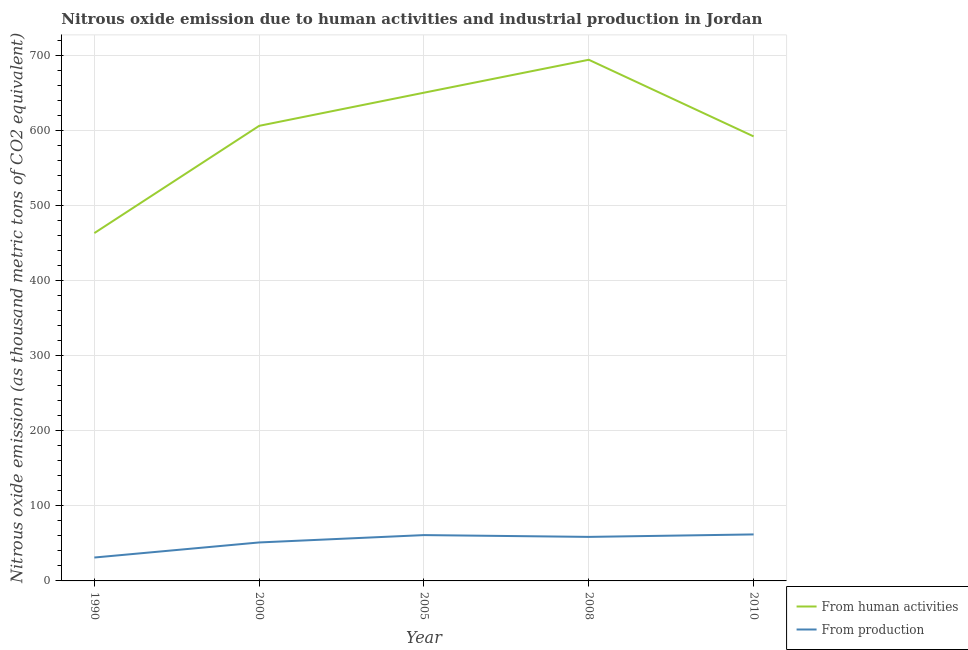Does the line corresponding to amount of emissions from human activities intersect with the line corresponding to amount of emissions generated from industries?
Your response must be concise. No. Is the number of lines equal to the number of legend labels?
Provide a succinct answer. Yes. What is the amount of emissions from human activities in 1990?
Give a very brief answer. 463.8. Across all years, what is the maximum amount of emissions from human activities?
Provide a succinct answer. 694.9. Across all years, what is the minimum amount of emissions from human activities?
Keep it short and to the point. 463.8. What is the total amount of emissions generated from industries in the graph?
Your answer should be very brief. 264.3. What is the difference between the amount of emissions from human activities in 1990 and that in 2000?
Offer a very short reply. -143. What is the difference between the amount of emissions from human activities in 2010 and the amount of emissions generated from industries in 1990?
Make the answer very short. 561.5. What is the average amount of emissions generated from industries per year?
Ensure brevity in your answer.  52.86. In the year 2008, what is the difference between the amount of emissions from human activities and amount of emissions generated from industries?
Provide a short and direct response. 636.2. What is the ratio of the amount of emissions from human activities in 2000 to that in 2005?
Keep it short and to the point. 0.93. Is the difference between the amount of emissions generated from industries in 2000 and 2010 greater than the difference between the amount of emissions from human activities in 2000 and 2010?
Offer a very short reply. No. What is the difference between the highest and the second highest amount of emissions generated from industries?
Offer a very short reply. 0.9. What is the difference between the highest and the lowest amount of emissions generated from industries?
Offer a terse response. 30.8. Does the amount of emissions from human activities monotonically increase over the years?
Your answer should be compact. No. How many lines are there?
Offer a very short reply. 2. Does the graph contain any zero values?
Offer a very short reply. No. Does the graph contain grids?
Ensure brevity in your answer.  Yes. Where does the legend appear in the graph?
Keep it short and to the point. Bottom right. What is the title of the graph?
Provide a short and direct response. Nitrous oxide emission due to human activities and industrial production in Jordan. What is the label or title of the Y-axis?
Offer a very short reply. Nitrous oxide emission (as thousand metric tons of CO2 equivalent). What is the Nitrous oxide emission (as thousand metric tons of CO2 equivalent) of From human activities in 1990?
Your answer should be compact. 463.8. What is the Nitrous oxide emission (as thousand metric tons of CO2 equivalent) in From production in 1990?
Give a very brief answer. 31.2. What is the Nitrous oxide emission (as thousand metric tons of CO2 equivalent) of From human activities in 2000?
Your answer should be compact. 606.8. What is the Nitrous oxide emission (as thousand metric tons of CO2 equivalent) of From production in 2000?
Keep it short and to the point. 51.3. What is the Nitrous oxide emission (as thousand metric tons of CO2 equivalent) in From human activities in 2005?
Make the answer very short. 651. What is the Nitrous oxide emission (as thousand metric tons of CO2 equivalent) of From production in 2005?
Offer a very short reply. 61.1. What is the Nitrous oxide emission (as thousand metric tons of CO2 equivalent) of From human activities in 2008?
Ensure brevity in your answer.  694.9. What is the Nitrous oxide emission (as thousand metric tons of CO2 equivalent) of From production in 2008?
Offer a terse response. 58.7. What is the Nitrous oxide emission (as thousand metric tons of CO2 equivalent) of From human activities in 2010?
Your answer should be compact. 592.7. Across all years, what is the maximum Nitrous oxide emission (as thousand metric tons of CO2 equivalent) of From human activities?
Keep it short and to the point. 694.9. Across all years, what is the minimum Nitrous oxide emission (as thousand metric tons of CO2 equivalent) in From human activities?
Offer a terse response. 463.8. Across all years, what is the minimum Nitrous oxide emission (as thousand metric tons of CO2 equivalent) in From production?
Ensure brevity in your answer.  31.2. What is the total Nitrous oxide emission (as thousand metric tons of CO2 equivalent) of From human activities in the graph?
Offer a very short reply. 3009.2. What is the total Nitrous oxide emission (as thousand metric tons of CO2 equivalent) in From production in the graph?
Keep it short and to the point. 264.3. What is the difference between the Nitrous oxide emission (as thousand metric tons of CO2 equivalent) of From human activities in 1990 and that in 2000?
Make the answer very short. -143. What is the difference between the Nitrous oxide emission (as thousand metric tons of CO2 equivalent) of From production in 1990 and that in 2000?
Your answer should be very brief. -20.1. What is the difference between the Nitrous oxide emission (as thousand metric tons of CO2 equivalent) in From human activities in 1990 and that in 2005?
Provide a succinct answer. -187.2. What is the difference between the Nitrous oxide emission (as thousand metric tons of CO2 equivalent) in From production in 1990 and that in 2005?
Your answer should be very brief. -29.9. What is the difference between the Nitrous oxide emission (as thousand metric tons of CO2 equivalent) in From human activities in 1990 and that in 2008?
Your response must be concise. -231.1. What is the difference between the Nitrous oxide emission (as thousand metric tons of CO2 equivalent) of From production in 1990 and that in 2008?
Your answer should be compact. -27.5. What is the difference between the Nitrous oxide emission (as thousand metric tons of CO2 equivalent) in From human activities in 1990 and that in 2010?
Ensure brevity in your answer.  -128.9. What is the difference between the Nitrous oxide emission (as thousand metric tons of CO2 equivalent) in From production in 1990 and that in 2010?
Your answer should be compact. -30.8. What is the difference between the Nitrous oxide emission (as thousand metric tons of CO2 equivalent) of From human activities in 2000 and that in 2005?
Your answer should be compact. -44.2. What is the difference between the Nitrous oxide emission (as thousand metric tons of CO2 equivalent) in From human activities in 2000 and that in 2008?
Provide a short and direct response. -88.1. What is the difference between the Nitrous oxide emission (as thousand metric tons of CO2 equivalent) of From human activities in 2000 and that in 2010?
Your answer should be compact. 14.1. What is the difference between the Nitrous oxide emission (as thousand metric tons of CO2 equivalent) in From human activities in 2005 and that in 2008?
Your response must be concise. -43.9. What is the difference between the Nitrous oxide emission (as thousand metric tons of CO2 equivalent) of From human activities in 2005 and that in 2010?
Ensure brevity in your answer.  58.3. What is the difference between the Nitrous oxide emission (as thousand metric tons of CO2 equivalent) in From human activities in 2008 and that in 2010?
Provide a succinct answer. 102.2. What is the difference between the Nitrous oxide emission (as thousand metric tons of CO2 equivalent) in From production in 2008 and that in 2010?
Ensure brevity in your answer.  -3.3. What is the difference between the Nitrous oxide emission (as thousand metric tons of CO2 equivalent) in From human activities in 1990 and the Nitrous oxide emission (as thousand metric tons of CO2 equivalent) in From production in 2000?
Ensure brevity in your answer.  412.5. What is the difference between the Nitrous oxide emission (as thousand metric tons of CO2 equivalent) of From human activities in 1990 and the Nitrous oxide emission (as thousand metric tons of CO2 equivalent) of From production in 2005?
Your answer should be compact. 402.7. What is the difference between the Nitrous oxide emission (as thousand metric tons of CO2 equivalent) in From human activities in 1990 and the Nitrous oxide emission (as thousand metric tons of CO2 equivalent) in From production in 2008?
Your answer should be very brief. 405.1. What is the difference between the Nitrous oxide emission (as thousand metric tons of CO2 equivalent) in From human activities in 1990 and the Nitrous oxide emission (as thousand metric tons of CO2 equivalent) in From production in 2010?
Offer a very short reply. 401.8. What is the difference between the Nitrous oxide emission (as thousand metric tons of CO2 equivalent) in From human activities in 2000 and the Nitrous oxide emission (as thousand metric tons of CO2 equivalent) in From production in 2005?
Offer a very short reply. 545.7. What is the difference between the Nitrous oxide emission (as thousand metric tons of CO2 equivalent) of From human activities in 2000 and the Nitrous oxide emission (as thousand metric tons of CO2 equivalent) of From production in 2008?
Your answer should be very brief. 548.1. What is the difference between the Nitrous oxide emission (as thousand metric tons of CO2 equivalent) in From human activities in 2000 and the Nitrous oxide emission (as thousand metric tons of CO2 equivalent) in From production in 2010?
Give a very brief answer. 544.8. What is the difference between the Nitrous oxide emission (as thousand metric tons of CO2 equivalent) of From human activities in 2005 and the Nitrous oxide emission (as thousand metric tons of CO2 equivalent) of From production in 2008?
Give a very brief answer. 592.3. What is the difference between the Nitrous oxide emission (as thousand metric tons of CO2 equivalent) of From human activities in 2005 and the Nitrous oxide emission (as thousand metric tons of CO2 equivalent) of From production in 2010?
Provide a succinct answer. 589. What is the difference between the Nitrous oxide emission (as thousand metric tons of CO2 equivalent) of From human activities in 2008 and the Nitrous oxide emission (as thousand metric tons of CO2 equivalent) of From production in 2010?
Your answer should be compact. 632.9. What is the average Nitrous oxide emission (as thousand metric tons of CO2 equivalent) of From human activities per year?
Give a very brief answer. 601.84. What is the average Nitrous oxide emission (as thousand metric tons of CO2 equivalent) in From production per year?
Offer a terse response. 52.86. In the year 1990, what is the difference between the Nitrous oxide emission (as thousand metric tons of CO2 equivalent) of From human activities and Nitrous oxide emission (as thousand metric tons of CO2 equivalent) of From production?
Provide a succinct answer. 432.6. In the year 2000, what is the difference between the Nitrous oxide emission (as thousand metric tons of CO2 equivalent) in From human activities and Nitrous oxide emission (as thousand metric tons of CO2 equivalent) in From production?
Your response must be concise. 555.5. In the year 2005, what is the difference between the Nitrous oxide emission (as thousand metric tons of CO2 equivalent) in From human activities and Nitrous oxide emission (as thousand metric tons of CO2 equivalent) in From production?
Your response must be concise. 589.9. In the year 2008, what is the difference between the Nitrous oxide emission (as thousand metric tons of CO2 equivalent) in From human activities and Nitrous oxide emission (as thousand metric tons of CO2 equivalent) in From production?
Your response must be concise. 636.2. In the year 2010, what is the difference between the Nitrous oxide emission (as thousand metric tons of CO2 equivalent) of From human activities and Nitrous oxide emission (as thousand metric tons of CO2 equivalent) of From production?
Provide a short and direct response. 530.7. What is the ratio of the Nitrous oxide emission (as thousand metric tons of CO2 equivalent) of From human activities in 1990 to that in 2000?
Make the answer very short. 0.76. What is the ratio of the Nitrous oxide emission (as thousand metric tons of CO2 equivalent) in From production in 1990 to that in 2000?
Provide a short and direct response. 0.61. What is the ratio of the Nitrous oxide emission (as thousand metric tons of CO2 equivalent) in From human activities in 1990 to that in 2005?
Give a very brief answer. 0.71. What is the ratio of the Nitrous oxide emission (as thousand metric tons of CO2 equivalent) in From production in 1990 to that in 2005?
Ensure brevity in your answer.  0.51. What is the ratio of the Nitrous oxide emission (as thousand metric tons of CO2 equivalent) of From human activities in 1990 to that in 2008?
Offer a very short reply. 0.67. What is the ratio of the Nitrous oxide emission (as thousand metric tons of CO2 equivalent) of From production in 1990 to that in 2008?
Make the answer very short. 0.53. What is the ratio of the Nitrous oxide emission (as thousand metric tons of CO2 equivalent) of From human activities in 1990 to that in 2010?
Your answer should be very brief. 0.78. What is the ratio of the Nitrous oxide emission (as thousand metric tons of CO2 equivalent) of From production in 1990 to that in 2010?
Provide a short and direct response. 0.5. What is the ratio of the Nitrous oxide emission (as thousand metric tons of CO2 equivalent) of From human activities in 2000 to that in 2005?
Make the answer very short. 0.93. What is the ratio of the Nitrous oxide emission (as thousand metric tons of CO2 equivalent) of From production in 2000 to that in 2005?
Keep it short and to the point. 0.84. What is the ratio of the Nitrous oxide emission (as thousand metric tons of CO2 equivalent) of From human activities in 2000 to that in 2008?
Keep it short and to the point. 0.87. What is the ratio of the Nitrous oxide emission (as thousand metric tons of CO2 equivalent) in From production in 2000 to that in 2008?
Provide a short and direct response. 0.87. What is the ratio of the Nitrous oxide emission (as thousand metric tons of CO2 equivalent) in From human activities in 2000 to that in 2010?
Your response must be concise. 1.02. What is the ratio of the Nitrous oxide emission (as thousand metric tons of CO2 equivalent) of From production in 2000 to that in 2010?
Ensure brevity in your answer.  0.83. What is the ratio of the Nitrous oxide emission (as thousand metric tons of CO2 equivalent) of From human activities in 2005 to that in 2008?
Ensure brevity in your answer.  0.94. What is the ratio of the Nitrous oxide emission (as thousand metric tons of CO2 equivalent) of From production in 2005 to that in 2008?
Your answer should be very brief. 1.04. What is the ratio of the Nitrous oxide emission (as thousand metric tons of CO2 equivalent) of From human activities in 2005 to that in 2010?
Your answer should be very brief. 1.1. What is the ratio of the Nitrous oxide emission (as thousand metric tons of CO2 equivalent) of From production in 2005 to that in 2010?
Ensure brevity in your answer.  0.99. What is the ratio of the Nitrous oxide emission (as thousand metric tons of CO2 equivalent) in From human activities in 2008 to that in 2010?
Ensure brevity in your answer.  1.17. What is the ratio of the Nitrous oxide emission (as thousand metric tons of CO2 equivalent) in From production in 2008 to that in 2010?
Offer a very short reply. 0.95. What is the difference between the highest and the second highest Nitrous oxide emission (as thousand metric tons of CO2 equivalent) in From human activities?
Provide a short and direct response. 43.9. What is the difference between the highest and the second highest Nitrous oxide emission (as thousand metric tons of CO2 equivalent) of From production?
Provide a succinct answer. 0.9. What is the difference between the highest and the lowest Nitrous oxide emission (as thousand metric tons of CO2 equivalent) in From human activities?
Provide a short and direct response. 231.1. What is the difference between the highest and the lowest Nitrous oxide emission (as thousand metric tons of CO2 equivalent) of From production?
Your answer should be very brief. 30.8. 